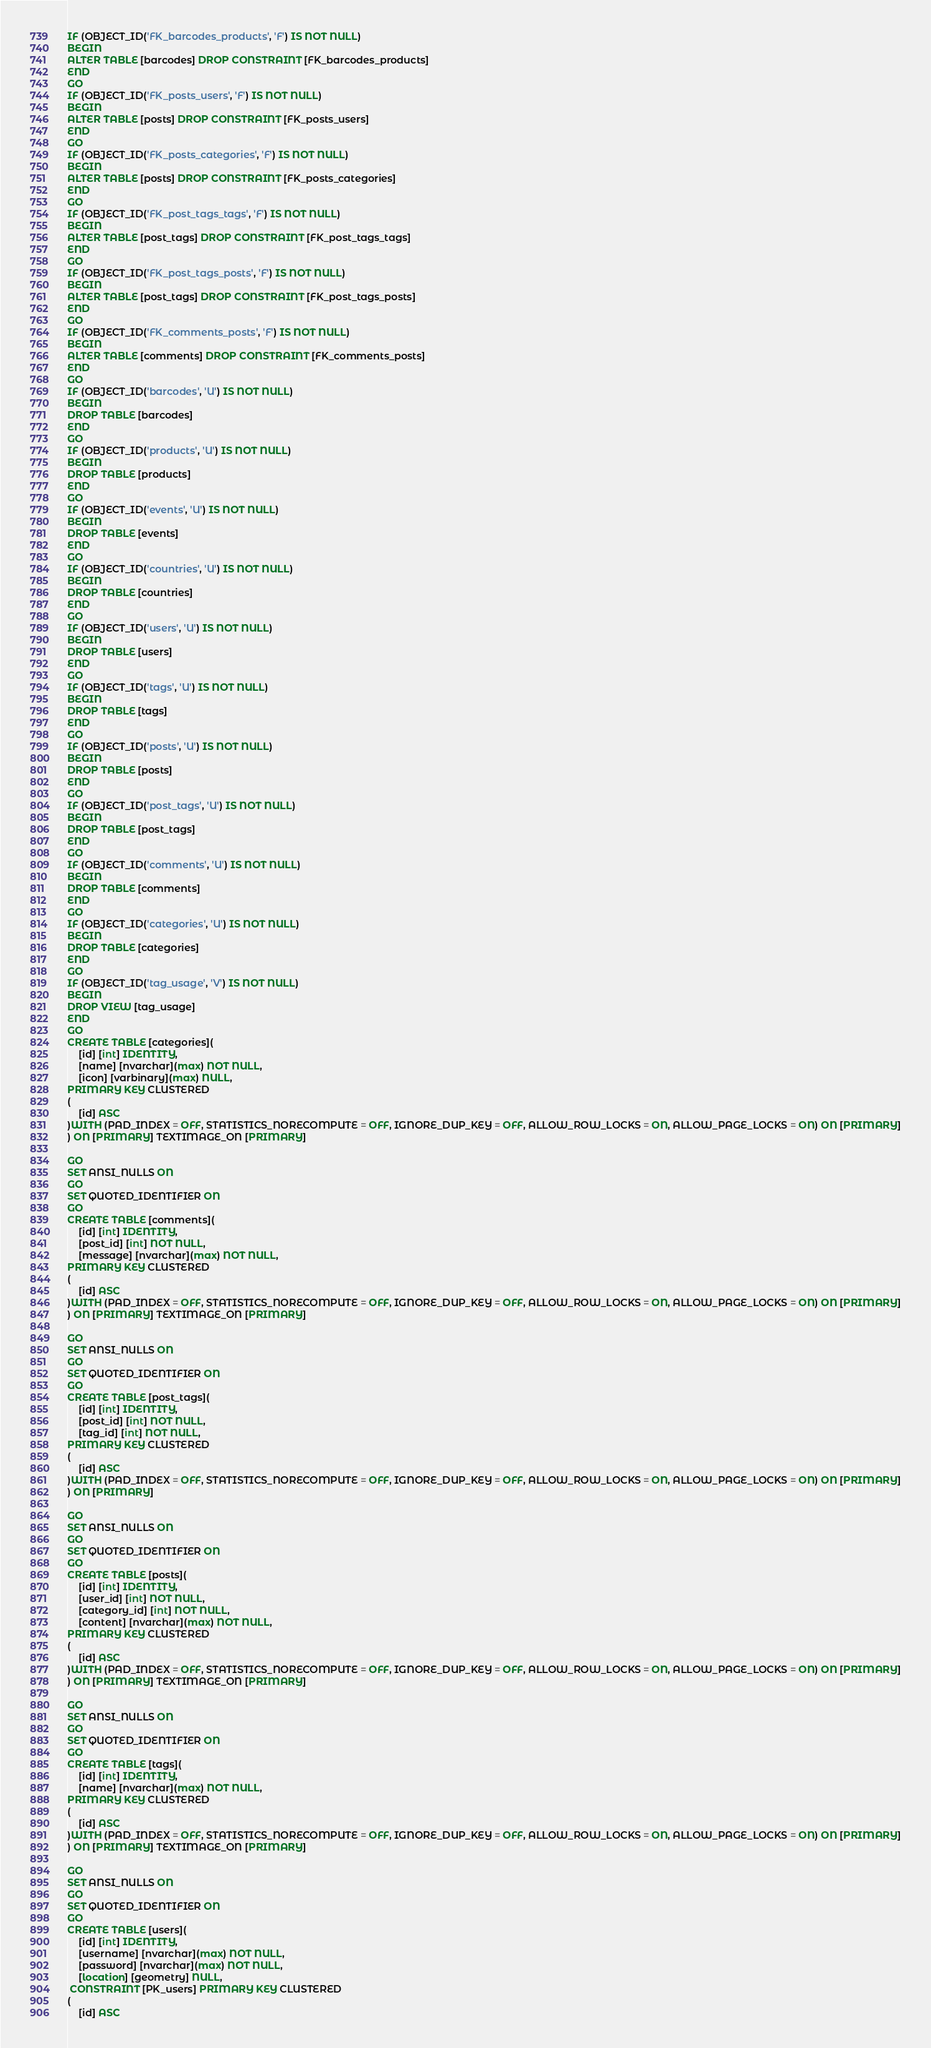<code> <loc_0><loc_0><loc_500><loc_500><_SQL_>IF (OBJECT_ID('FK_barcodes_products', 'F') IS NOT NULL)
BEGIN
ALTER TABLE [barcodes] DROP CONSTRAINT [FK_barcodes_products]
END
GO
IF (OBJECT_ID('FK_posts_users', 'F') IS NOT NULL)
BEGIN
ALTER TABLE [posts] DROP CONSTRAINT [FK_posts_users]
END
GO
IF (OBJECT_ID('FK_posts_categories', 'F') IS NOT NULL)
BEGIN
ALTER TABLE [posts] DROP CONSTRAINT [FK_posts_categories]
END
GO
IF (OBJECT_ID('FK_post_tags_tags', 'F') IS NOT NULL)
BEGIN
ALTER TABLE [post_tags] DROP CONSTRAINT [FK_post_tags_tags]
END
GO
IF (OBJECT_ID('FK_post_tags_posts', 'F') IS NOT NULL)
BEGIN
ALTER TABLE [post_tags] DROP CONSTRAINT [FK_post_tags_posts]
END
GO
IF (OBJECT_ID('FK_comments_posts', 'F') IS NOT NULL)
BEGIN
ALTER TABLE [comments] DROP CONSTRAINT [FK_comments_posts]
END
GO
IF (OBJECT_ID('barcodes', 'U') IS NOT NULL)
BEGIN
DROP TABLE [barcodes]
END
GO
IF (OBJECT_ID('products', 'U') IS NOT NULL)
BEGIN
DROP TABLE [products]
END
GO
IF (OBJECT_ID('events', 'U') IS NOT NULL)
BEGIN
DROP TABLE [events]
END
GO
IF (OBJECT_ID('countries', 'U') IS NOT NULL)
BEGIN
DROP TABLE [countries]
END
GO
IF (OBJECT_ID('users', 'U') IS NOT NULL)
BEGIN
DROP TABLE [users]
END
GO
IF (OBJECT_ID('tags', 'U') IS NOT NULL)
BEGIN
DROP TABLE [tags]
END
GO
IF (OBJECT_ID('posts', 'U') IS NOT NULL)
BEGIN
DROP TABLE [posts]
END
GO
IF (OBJECT_ID('post_tags', 'U') IS NOT NULL)
BEGIN
DROP TABLE [post_tags]
END
GO
IF (OBJECT_ID('comments', 'U') IS NOT NULL)
BEGIN
DROP TABLE [comments]
END
GO
IF (OBJECT_ID('categories', 'U') IS NOT NULL)
BEGIN
DROP TABLE [categories]
END
GO
IF (OBJECT_ID('tag_usage', 'V') IS NOT NULL)
BEGIN
DROP VIEW [tag_usage]
END
GO
CREATE TABLE [categories](
	[id] [int] IDENTITY,
	[name] [nvarchar](max) NOT NULL,
	[icon] [varbinary](max) NULL,
PRIMARY KEY CLUSTERED
(
	[id] ASC
)WITH (PAD_INDEX = OFF, STATISTICS_NORECOMPUTE = OFF, IGNORE_DUP_KEY = OFF, ALLOW_ROW_LOCKS = ON, ALLOW_PAGE_LOCKS = ON) ON [PRIMARY]
) ON [PRIMARY] TEXTIMAGE_ON [PRIMARY]

GO
SET ANSI_NULLS ON
GO
SET QUOTED_IDENTIFIER ON
GO
CREATE TABLE [comments](
	[id] [int] IDENTITY,
	[post_id] [int] NOT NULL,
	[message] [nvarchar](max) NOT NULL,
PRIMARY KEY CLUSTERED
(
	[id] ASC
)WITH (PAD_INDEX = OFF, STATISTICS_NORECOMPUTE = OFF, IGNORE_DUP_KEY = OFF, ALLOW_ROW_LOCKS = ON, ALLOW_PAGE_LOCKS = ON) ON [PRIMARY]
) ON [PRIMARY] TEXTIMAGE_ON [PRIMARY]

GO
SET ANSI_NULLS ON
GO
SET QUOTED_IDENTIFIER ON
GO
CREATE TABLE [post_tags](
	[id] [int] IDENTITY,
	[post_id] [int] NOT NULL,
	[tag_id] [int] NOT NULL,
PRIMARY KEY CLUSTERED
(
	[id] ASC
)WITH (PAD_INDEX = OFF, STATISTICS_NORECOMPUTE = OFF, IGNORE_DUP_KEY = OFF, ALLOW_ROW_LOCKS = ON, ALLOW_PAGE_LOCKS = ON) ON [PRIMARY]
) ON [PRIMARY]

GO
SET ANSI_NULLS ON
GO
SET QUOTED_IDENTIFIER ON
GO
CREATE TABLE [posts](
	[id] [int] IDENTITY,
	[user_id] [int] NOT NULL,
	[category_id] [int] NOT NULL,
	[content] [nvarchar](max) NOT NULL,
PRIMARY KEY CLUSTERED
(
	[id] ASC
)WITH (PAD_INDEX = OFF, STATISTICS_NORECOMPUTE = OFF, IGNORE_DUP_KEY = OFF, ALLOW_ROW_LOCKS = ON, ALLOW_PAGE_LOCKS = ON) ON [PRIMARY]
) ON [PRIMARY] TEXTIMAGE_ON [PRIMARY]

GO
SET ANSI_NULLS ON
GO
SET QUOTED_IDENTIFIER ON
GO
CREATE TABLE [tags](
	[id] [int] IDENTITY,
	[name] [nvarchar](max) NOT NULL,
PRIMARY KEY CLUSTERED
(
	[id] ASC
)WITH (PAD_INDEX = OFF, STATISTICS_NORECOMPUTE = OFF, IGNORE_DUP_KEY = OFF, ALLOW_ROW_LOCKS = ON, ALLOW_PAGE_LOCKS = ON) ON [PRIMARY]
) ON [PRIMARY] TEXTIMAGE_ON [PRIMARY]

GO
SET ANSI_NULLS ON
GO
SET QUOTED_IDENTIFIER ON
GO
CREATE TABLE [users](
	[id] [int] IDENTITY,
	[username] [nvarchar](max) NOT NULL,
	[password] [nvarchar](max) NOT NULL,
	[location] [geometry] NULL,
 CONSTRAINT [PK_users] PRIMARY KEY CLUSTERED
(
	[id] ASC</code> 